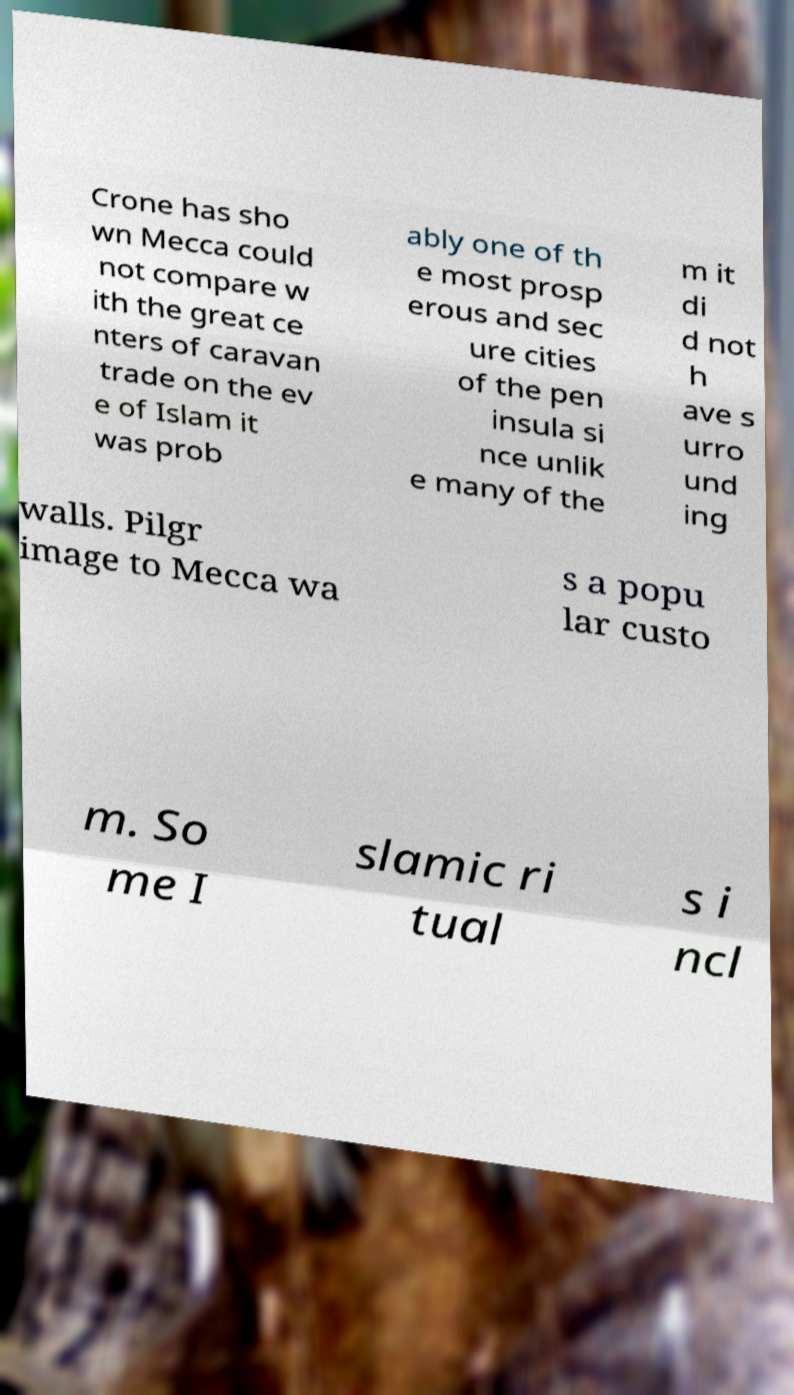What messages or text are displayed in this image? I need them in a readable, typed format. Crone has sho wn Mecca could not compare w ith the great ce nters of caravan trade on the ev e of Islam it was prob ably one of th e most prosp erous and sec ure cities of the pen insula si nce unlik e many of the m it di d not h ave s urro und ing walls. Pilgr image to Mecca wa s a popu lar custo m. So me I slamic ri tual s i ncl 